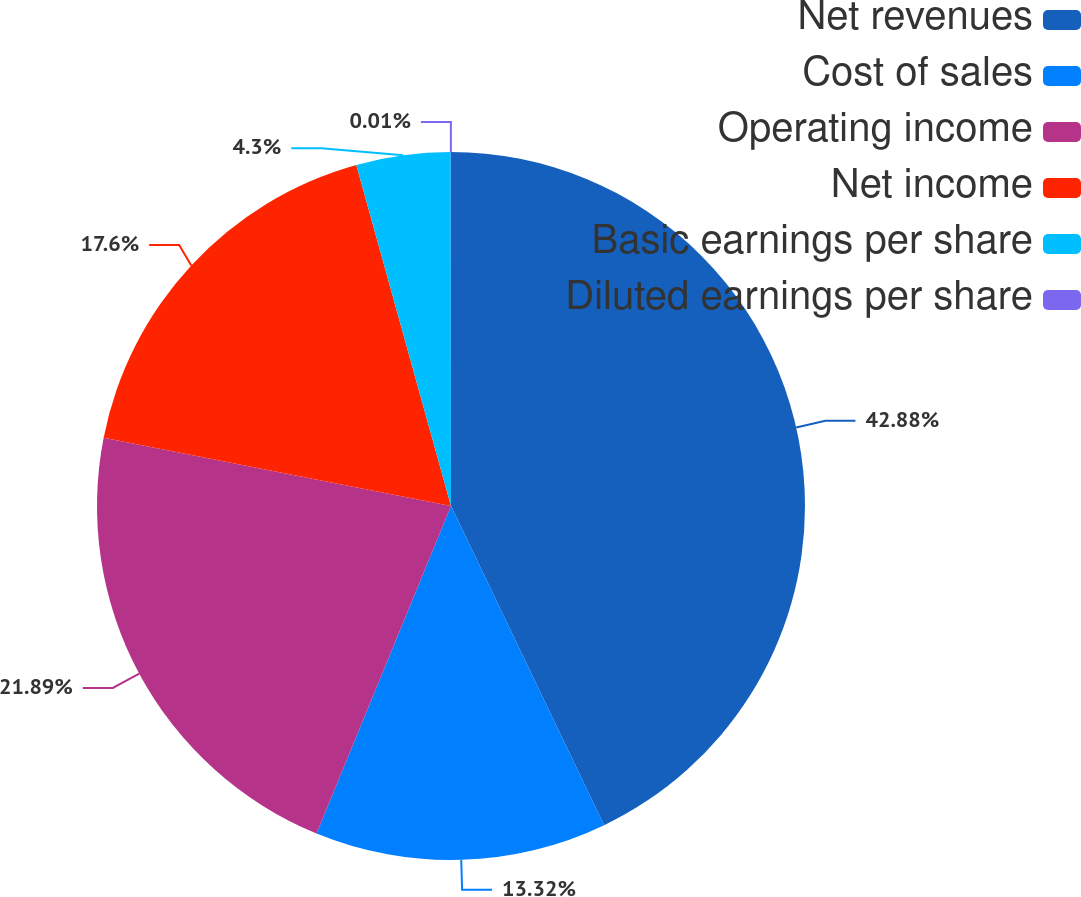<chart> <loc_0><loc_0><loc_500><loc_500><pie_chart><fcel>Net revenues<fcel>Cost of sales<fcel>Operating income<fcel>Net income<fcel>Basic earnings per share<fcel>Diluted earnings per share<nl><fcel>42.88%<fcel>13.32%<fcel>21.89%<fcel>17.6%<fcel>4.3%<fcel>0.01%<nl></chart> 